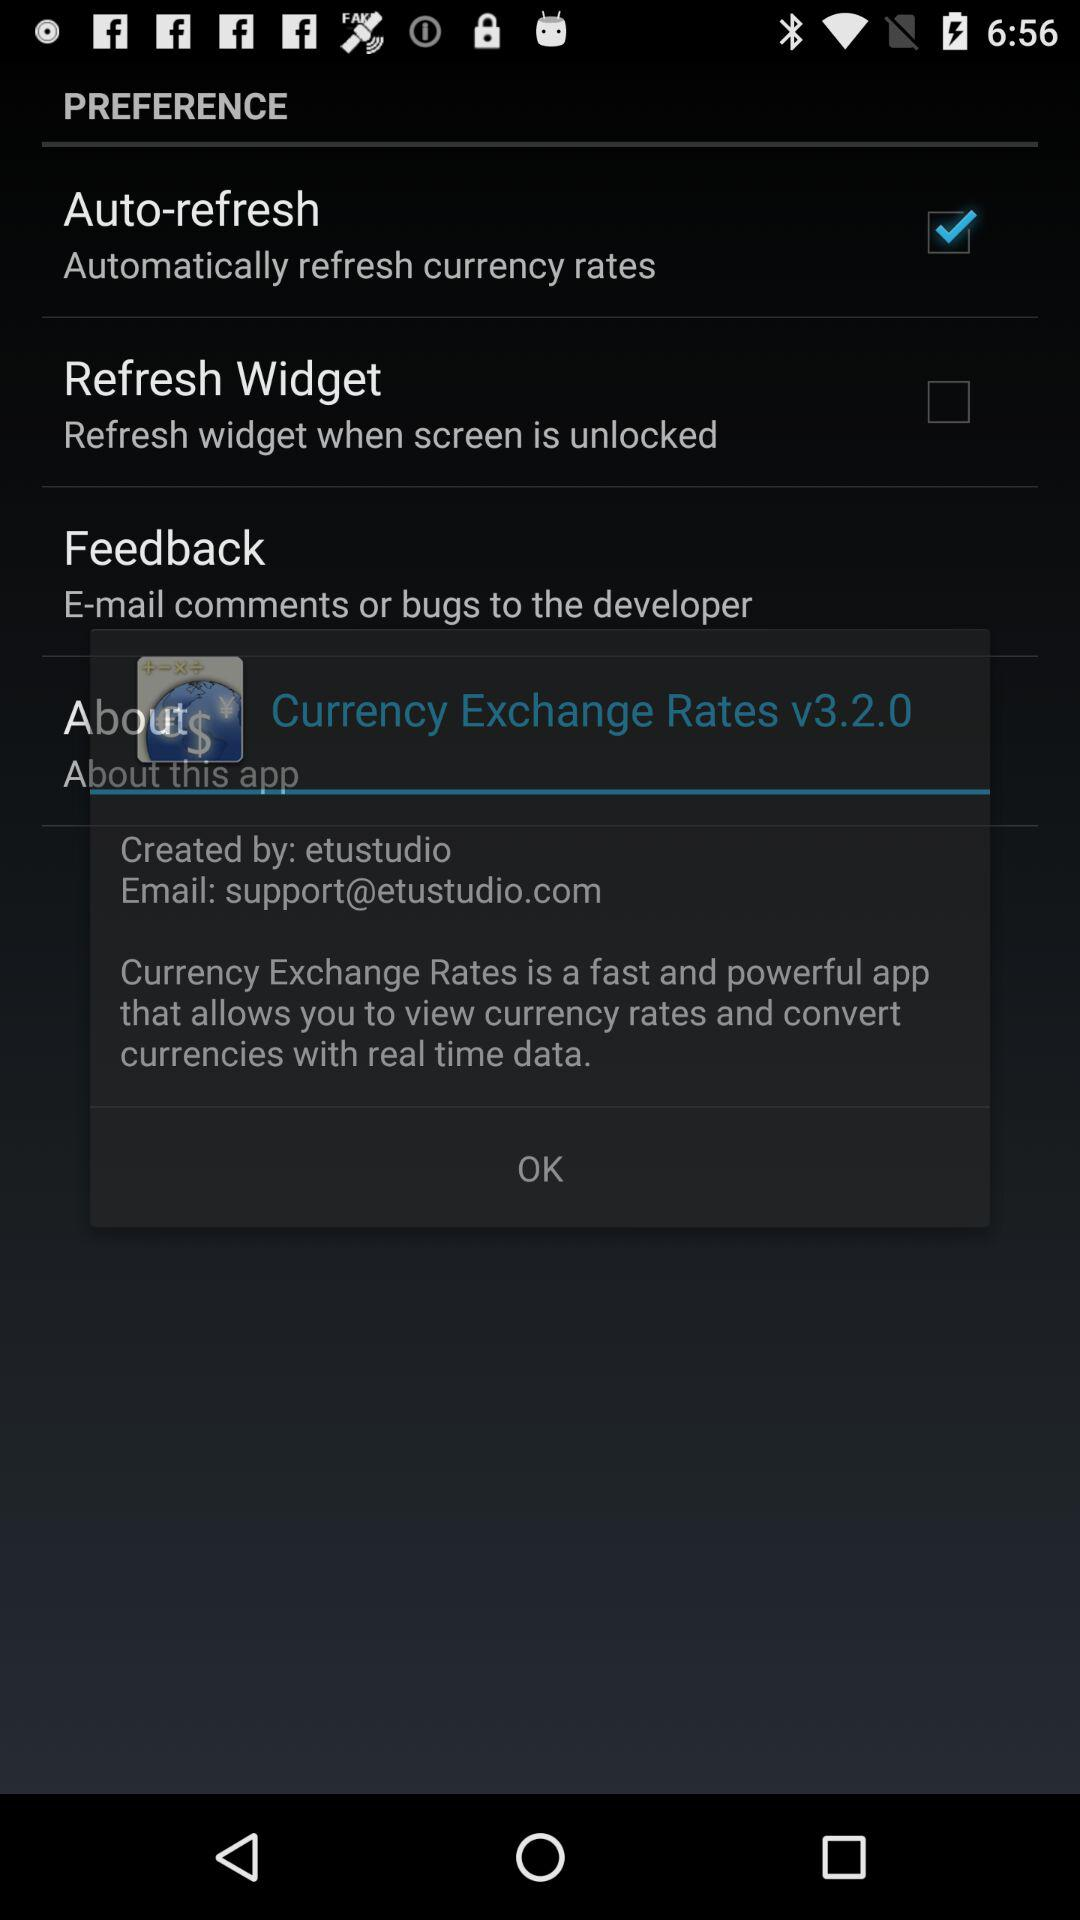How many USD are equivalent to 1 EUR? 1 EUR is equivalent to 1.0693 USD. 